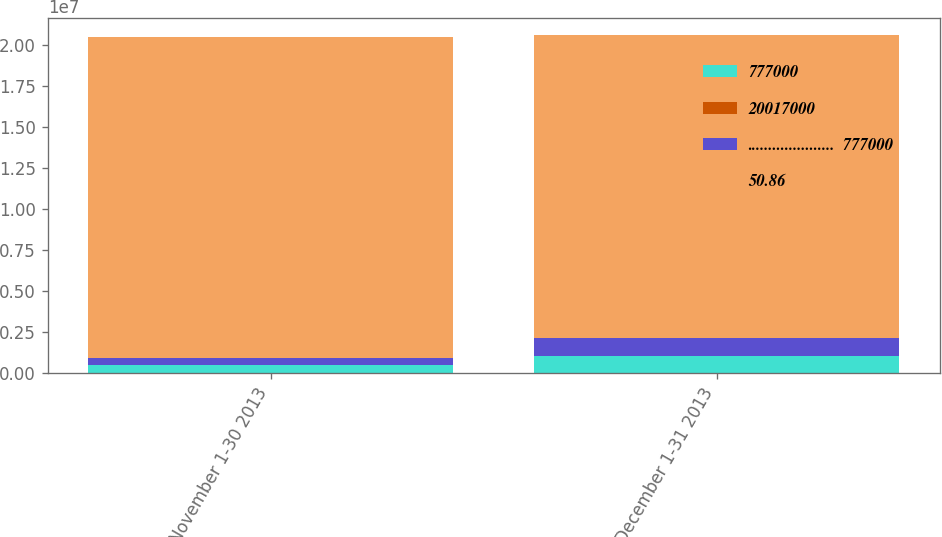Convert chart to OTSL. <chart><loc_0><loc_0><loc_500><loc_500><stacked_bar_chart><ecel><fcel>November 1-30 2013<fcel>December 1-31 2013<nl><fcel>777000<fcel>450000<fcel>1.05e+06<nl><fcel>20017000<fcel>54.69<fcel>56.69<nl><fcel>.....................  777000<fcel>450000<fcel>1.05e+06<nl><fcel>50.86<fcel>1.9567e+07<fcel>1.8517e+07<nl></chart> 